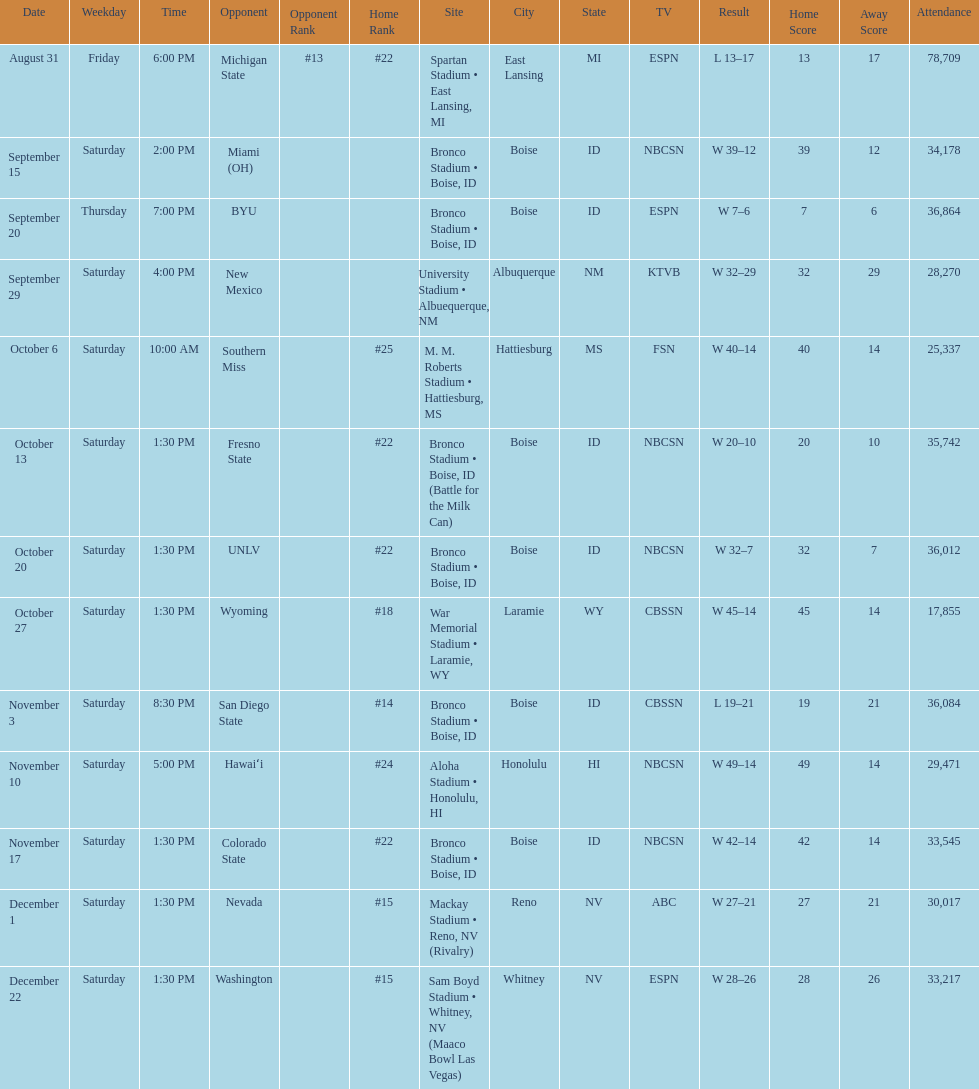What was the most consecutive wins for the team shown in the season? 7. 